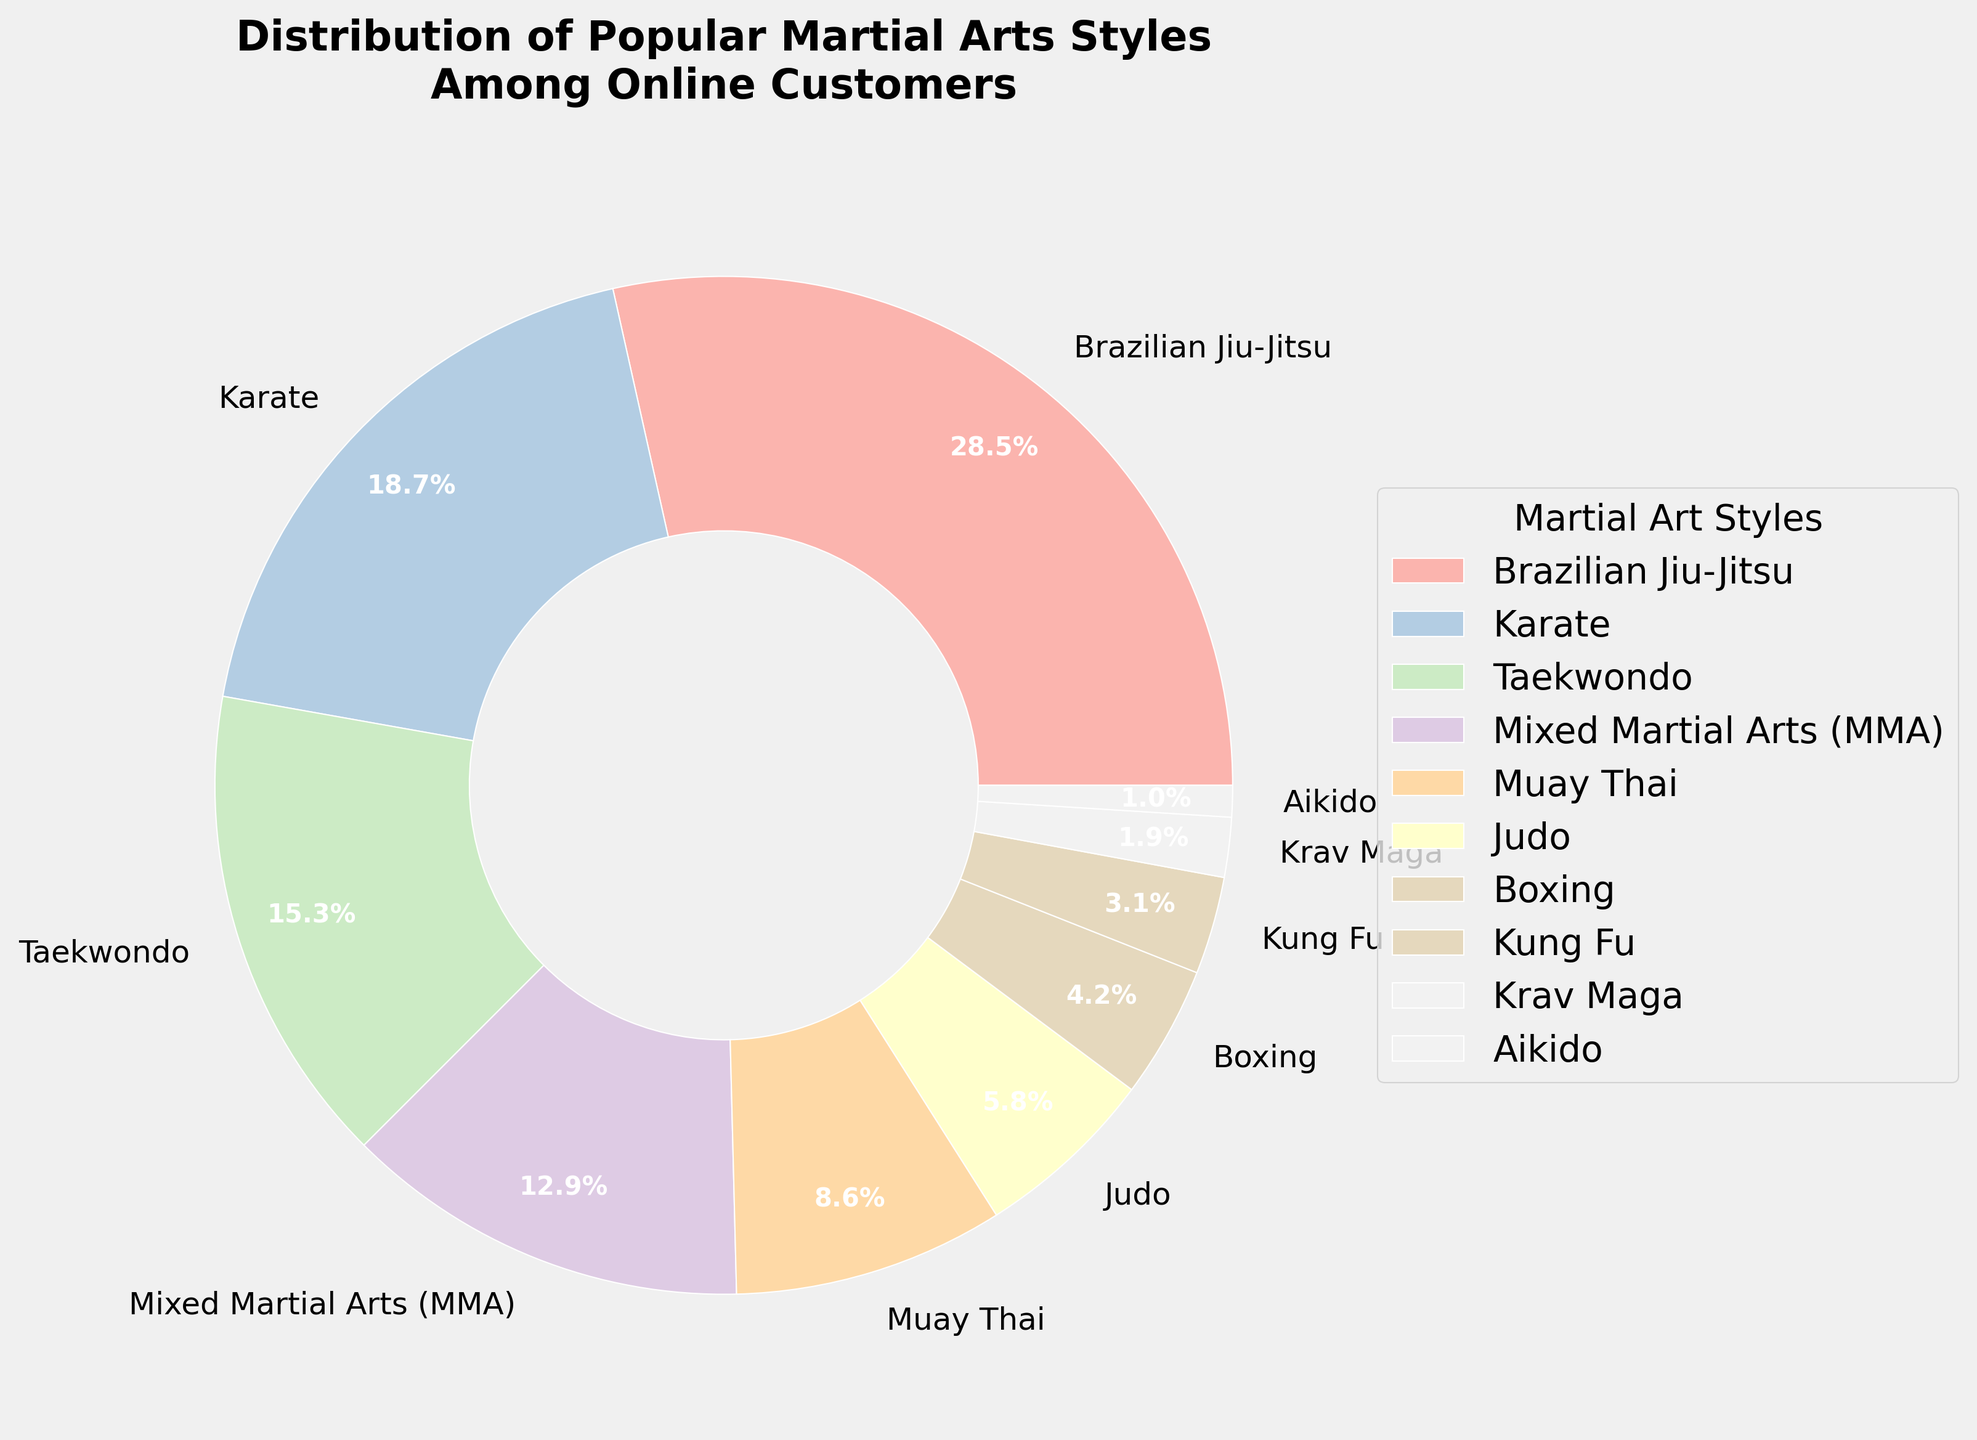who are the top three martial arts styles by popularity? To determine the top three styles, examine the percentages within the pie chart. Brazilian Jiu-Jitsu stands at 28.5%, Karate at 18.7%, and Taekwondo at 15.3%. These three have the highest shares.
Answer: Brazilian Jiu-Jitsu, Karate, Taekwondo Which martial art style has the smallest representation among online customers? Check the smallest wedge in the pie chart. The style with the lowest percentage is Aikido at 1.0%.
Answer: Aikido What is the collective percentage of Brazilian Jiu-Jitsu, Karate, and Taekwondo? Sum the individual percentages for these three styles: 28.5% (Brazilian Jiu-Jitsu) + 18.7% (Karate) + 15.3% (Taekwondo) = 62.5%.
Answer: 62.5% How does the popularity of Mixed Martial Arts (MMA) compare to Judo? Compare the two percentages: MMA is 12.9% and Judo is 5.8%. MMA has a higher percentage.
Answer: MMA is more popular than Judo What is the percentage difference between Muay Thai and Krav Maga? Subtract the percentage of Krav Maga from Muay Thai: 8.6% (Muay Thai) - 1.9% (Krav Maga) = 6.7%.
Answer: 6.7% Is the combined share of Kung Fu and Aikido greater than Boxing? Sum Kung Fu and Aikido percentages (3.1% + 1.0%) and compare to Boxing (4.2%): 4.1% for Kung Fu and Aikido which is less than 4.2%.
Answer: No Which martial art styles have a percentage less than 5%? Identify styles with percentages below 5%: Judo (5.8%) is above 5%, so Boxing (4.2%), Kung Fu (3.1%), Krav Maga (1.9%), and Aikido (1.0%) qualify.
Answer: Boxing, Kung Fu, Krav Maga, Aikido If a pie chart wedge is the darkest color used, what martial art does it represent? The darkest segment in the Pastel1 color palette corresponds to the first portion allocated, generally representing Brazilian Jiu-Jitsu.
Answer: Brazilian Jiu-Jitsu 